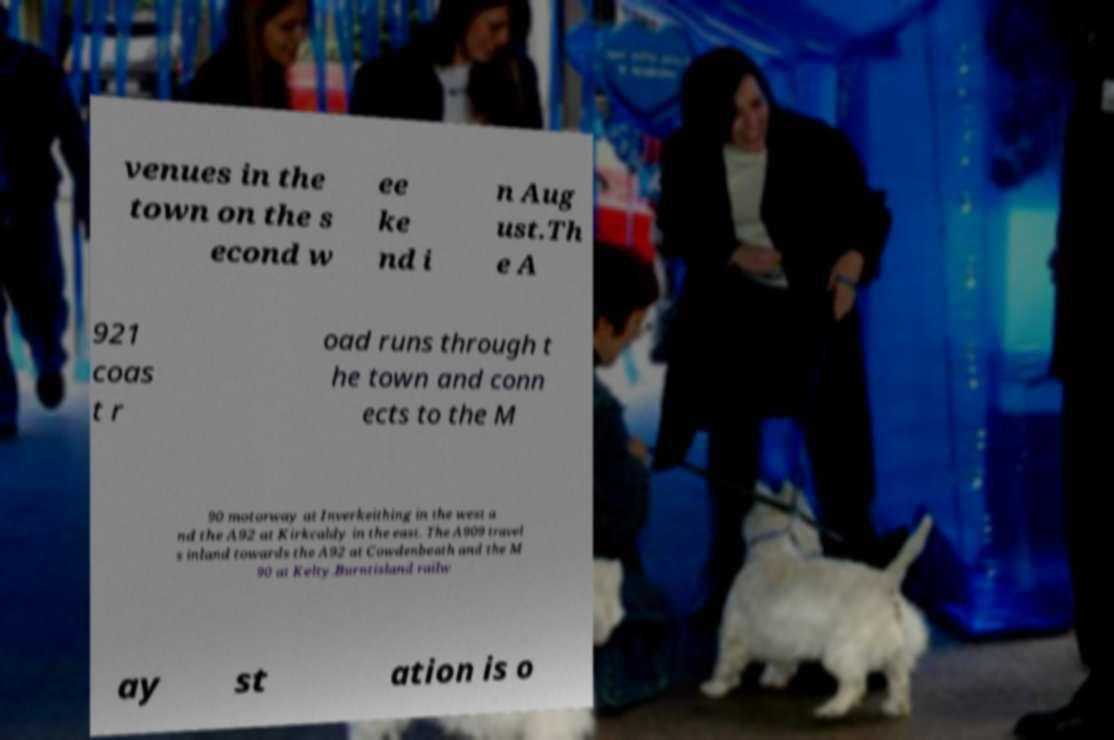Could you assist in decoding the text presented in this image and type it out clearly? venues in the town on the s econd w ee ke nd i n Aug ust.Th e A 921 coas t r oad runs through t he town and conn ects to the M 90 motorway at Inverkeithing in the west a nd the A92 at Kirkcaldy in the east. The A909 travel s inland towards the A92 at Cowdenbeath and the M 90 at Kelty.Burntisland railw ay st ation is o 